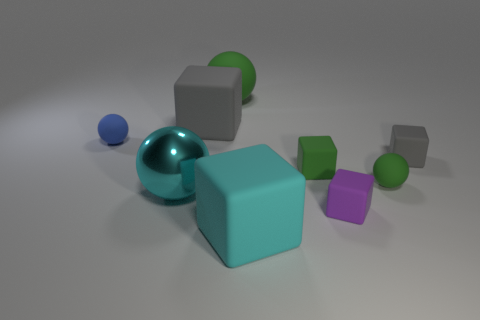Subtract all yellow blocks. Subtract all red cylinders. How many blocks are left? 5 Add 1 red shiny cylinders. How many objects exist? 10 Subtract all blocks. How many objects are left? 4 Add 8 large gray cubes. How many large gray cubes are left? 9 Add 6 tiny green objects. How many tiny green objects exist? 8 Subtract 0 yellow cubes. How many objects are left? 9 Subtract all large spheres. Subtract all big gray matte things. How many objects are left? 6 